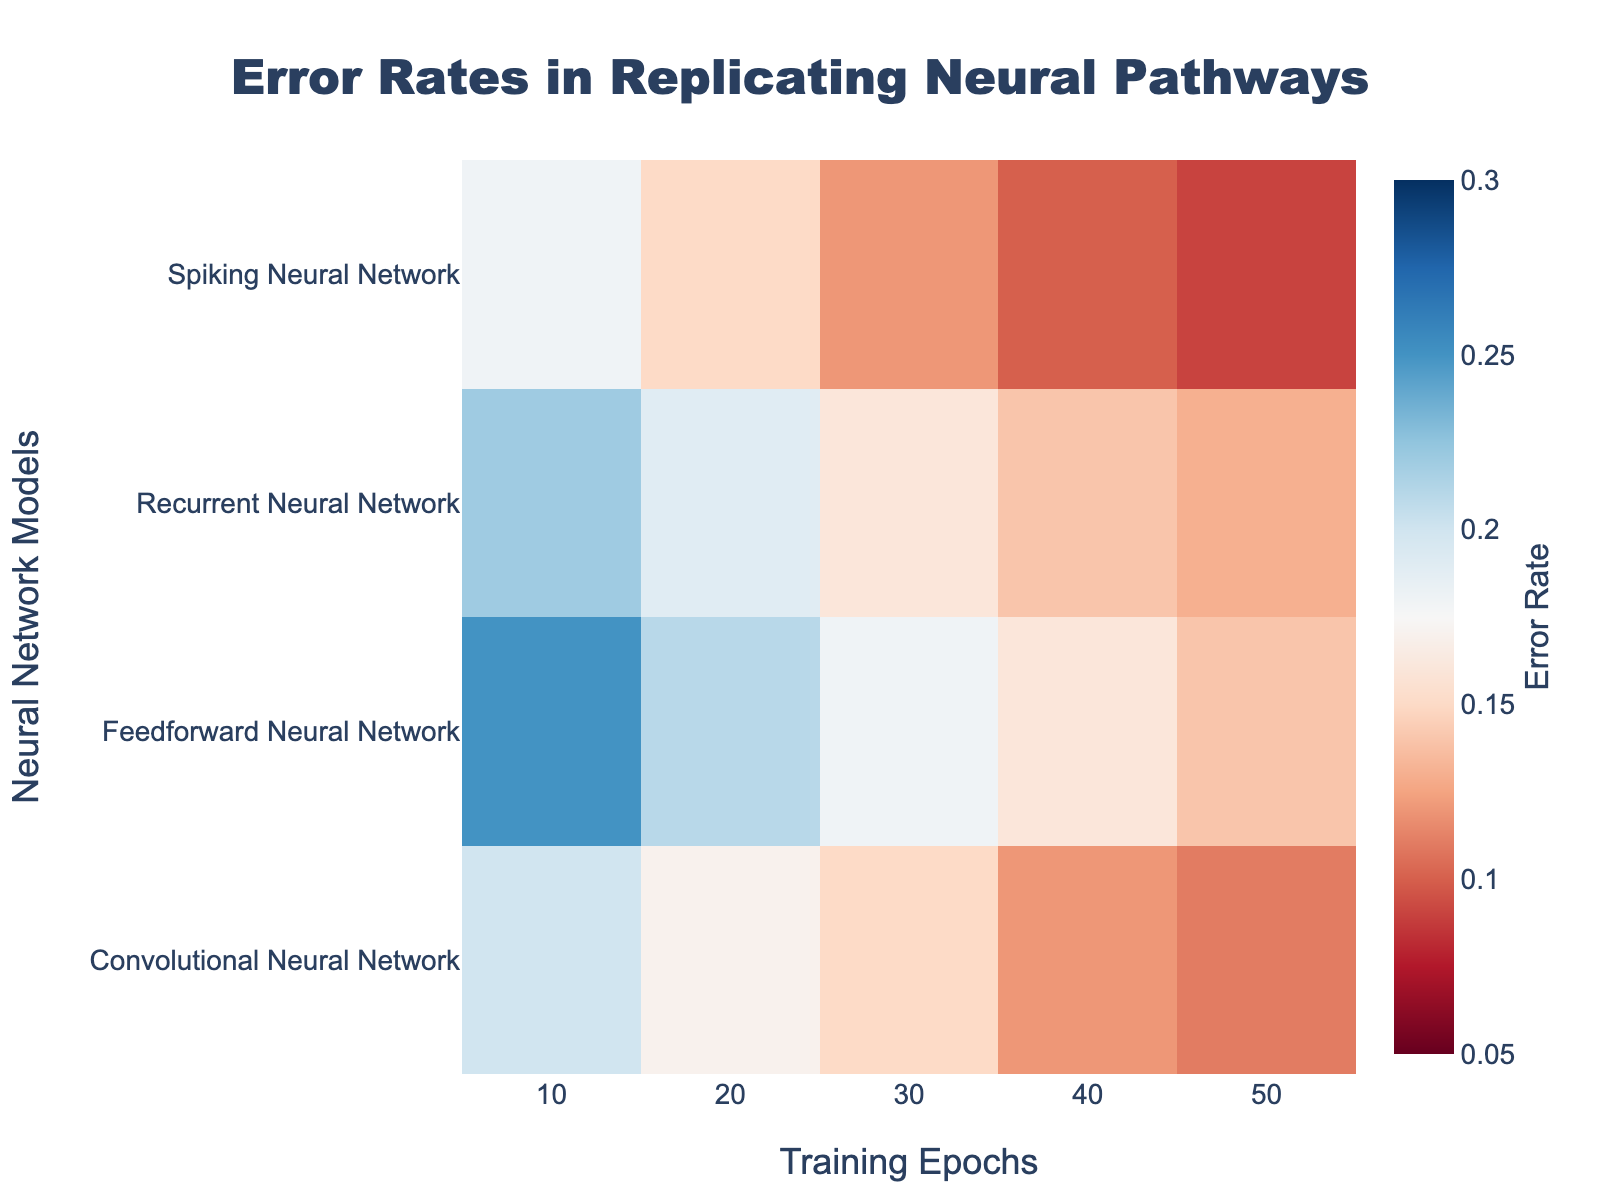What's the title of the heatmap? Look at the top center of the heatmap; the title should be prominently displayed in a larger font.
Answer: Error Rates in Replicating Neural Pathways What is the error rate of the Feedforward Neural Network at 30 training epochs? Locate the "Feedforward Neural Network" row and follow it horizontally to the column for 30 training epochs. The cell at this intersection contains the error rate.
Answer: 0.18 Which neural network model has the lowest error rate at 50 training epochs? Compare the error rates at 50 training epochs across all models. The smallest value corresponds to the model with the lowest error rate.
Answer: Spiking Neural Network How does the error rate of the Recurrent Neural Network change from 10 to 50 training epochs? Examine the error rates for the Recurrent Neural Network across the different training epochs (10, 20, 30, 40, 50). Note the trend by observing whether the values increase or decrease.
Answer: It decreases from 0.22 to 0.13 Which model shows the most significant reduction in error rate from 10 to 50 training epochs? Calculate the difference in error rates at 50 and 10 training epochs for each model. Compare these differences to identify the model with the largest reduction.
Answer: Feedforward Neural Network What's the difference in error rate between the Spiking Neural Network and Convolutional Neural Network at 40 training epochs? Find the error rates for Spiking Neural Network and Convolutional Neural Network at 40 training epochs. Subtract the smaller error rate from the larger one.
Answer: 0.02 (0.12 - 0.10) Are there any models where the error rate does not decrease consistently with more training epochs? Scan through each row (model) to check if there are non-decreasing error rates with increasing training epochs.
Answer: No Which model has the highest error rate at 20 training epochs? Identify the error rates across models at 20 training epochs and pick the largest value.
Answer: Feedforward Neural Network Does the color intensity increase or decrease with lower error rates? Interpret the heatmap color scale: observe the color gradient and correlate it to the error rates. Cool colors (towards blue) generally represent lower values.
Answer: Increases (cooler colors are lower) Is there any model whose error rate at 10 training epochs is higher than the error rate of the Spiking Neural Network at 50 training epochs? Compare the error rates at 10 training epochs for all models with the error rate of the Spiking Neural Network at 50 training epochs. Check if any is greater.
Answer: Yes, all models except Spiking Neural Network 